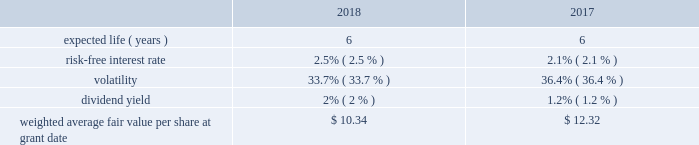Bhge 2018 form 10-k | 85 it is expected that the amount of unrecognized tax benefits will change in the next twelve months due to expiring statutes , audit activity , tax payments , and competent authority proceedings related to transfer pricing or final decisions in matters that are the subject of litigation in various taxing jurisdictions in which we operate .
At december 31 , 2018 , we had approximately $ 96 million of tax liabilities , net of $ 1 million of tax assets , related to uncertain tax positions , each of which are individually insignificant , and each of which are reasonably possible of being settled within the next twelve months .
We conduct business in more than 120 countries and are subject to income taxes in most taxing jurisdictions in which we operate .
All internal revenue service examinations have been completed and closed through year end 2015 for the most significant u.s .
Returns .
We believe there are no other jurisdictions in which the outcome of unresolved issues or claims is likely to be material to our results of operations , financial position or cash flows .
We further believe that we have made adequate provision for all income tax uncertainties .
Note 13 .
Stock-based compensation in july 2017 , we adopted the bhge 2017 long-term incentive plan ( lti plan ) under which we may grant stock options and other equity-based awards to employees and non-employee directors providing services to the company and our subsidiaries .
A total of up to 57.4 million shares of class a common stock are authorized for issuance pursuant to awards granted under the lti plan over its term which expires on the date of the annual meeting of the company in 2027 .
A total of 46.2 million shares of class a common stock are available for issuance as of december 31 , 2018 .
Stock-based compensation cost was $ 121 million and $ 37 million in 2018 and 2017 , respectively .
Stock-based compensation cost is measured at the date of grant based on the calculated fair value of the award and is generally recognized on a straight-line basis over the vesting period of the equity grant .
The compensation cost is determined based on awards ultimately expected to vest ; therefore , we have reduced the cost for estimated forfeitures based on historical forfeiture rates .
Forfeitures are estimated at the time of grant and revised , if necessary , in subsequent periods to reflect actual forfeitures .
There were no stock-based compensation costs capitalized as the amounts were not material .
Stock options we may grant stock options to our officers , directors and key employees .
Stock options generally vest in equal amounts over a three-year vesting period provided that the employee has remained continuously employed by the company through such vesting date .
The fair value of each stock option granted is estimated using the black- scholes option pricing model .
The table presents the weighted average assumptions used in the option pricing model for options granted under the lti plan .
The expected life of the options represents the period of time the options are expected to be outstanding .
The expected life is based on a simple average of the vesting term and original contractual term of the awards .
The expected volatility is based on the historical volatility of our five main competitors over a six year period .
The risk-free interest rate is based on the observed u.s .
Treasury yield curve in effect at the time the options were granted .
The dividend yield is based on a five year history of dividend payouts in baker hughes. .
Baker hughes , a ge company notes to consolidated and combined financial statements .
What is the percent change in weighted average fair value per share at grant date from 2017 to 2018? 
Computations: ((12.32 - 10.34) / 10.34)
Answer: 0.19149. Bhge 2018 form 10-k | 85 it is expected that the amount of unrecognized tax benefits will change in the next twelve months due to expiring statutes , audit activity , tax payments , and competent authority proceedings related to transfer pricing or final decisions in matters that are the subject of litigation in various taxing jurisdictions in which we operate .
At december 31 , 2018 , we had approximately $ 96 million of tax liabilities , net of $ 1 million of tax assets , related to uncertain tax positions , each of which are individually insignificant , and each of which are reasonably possible of being settled within the next twelve months .
We conduct business in more than 120 countries and are subject to income taxes in most taxing jurisdictions in which we operate .
All internal revenue service examinations have been completed and closed through year end 2015 for the most significant u.s .
Returns .
We believe there are no other jurisdictions in which the outcome of unresolved issues or claims is likely to be material to our results of operations , financial position or cash flows .
We further believe that we have made adequate provision for all income tax uncertainties .
Note 13 .
Stock-based compensation in july 2017 , we adopted the bhge 2017 long-term incentive plan ( lti plan ) under which we may grant stock options and other equity-based awards to employees and non-employee directors providing services to the company and our subsidiaries .
A total of up to 57.4 million shares of class a common stock are authorized for issuance pursuant to awards granted under the lti plan over its term which expires on the date of the annual meeting of the company in 2027 .
A total of 46.2 million shares of class a common stock are available for issuance as of december 31 , 2018 .
Stock-based compensation cost was $ 121 million and $ 37 million in 2018 and 2017 , respectively .
Stock-based compensation cost is measured at the date of grant based on the calculated fair value of the award and is generally recognized on a straight-line basis over the vesting period of the equity grant .
The compensation cost is determined based on awards ultimately expected to vest ; therefore , we have reduced the cost for estimated forfeitures based on historical forfeiture rates .
Forfeitures are estimated at the time of grant and revised , if necessary , in subsequent periods to reflect actual forfeitures .
There were no stock-based compensation costs capitalized as the amounts were not material .
Stock options we may grant stock options to our officers , directors and key employees .
Stock options generally vest in equal amounts over a three-year vesting period provided that the employee has remained continuously employed by the company through such vesting date .
The fair value of each stock option granted is estimated using the black- scholes option pricing model .
The table presents the weighted average assumptions used in the option pricing model for options granted under the lti plan .
The expected life of the options represents the period of time the options are expected to be outstanding .
The expected life is based on a simple average of the vesting term and original contractual term of the awards .
The expected volatility is based on the historical volatility of our five main competitors over a six year period .
The risk-free interest rate is based on the observed u.s .
Treasury yield curve in effect at the time the options were granted .
The dividend yield is based on a five year history of dividend payouts in baker hughes. .
Baker hughes , a ge company notes to consolidated and combined financial statements .
What is the dividend yield of the stock-based compensation cost in 2018? 
Computations: (2% * 121)
Answer: 2.42. Bhge 2018 form 10-k | 85 it is expected that the amount of unrecognized tax benefits will change in the next twelve months due to expiring statutes , audit activity , tax payments , and competent authority proceedings related to transfer pricing or final decisions in matters that are the subject of litigation in various taxing jurisdictions in which we operate .
At december 31 , 2018 , we had approximately $ 96 million of tax liabilities , net of $ 1 million of tax assets , related to uncertain tax positions , each of which are individually insignificant , and each of which are reasonably possible of being settled within the next twelve months .
We conduct business in more than 120 countries and are subject to income taxes in most taxing jurisdictions in which we operate .
All internal revenue service examinations have been completed and closed through year end 2015 for the most significant u.s .
Returns .
We believe there are no other jurisdictions in which the outcome of unresolved issues or claims is likely to be material to our results of operations , financial position or cash flows .
We further believe that we have made adequate provision for all income tax uncertainties .
Note 13 .
Stock-based compensation in july 2017 , we adopted the bhge 2017 long-term incentive plan ( lti plan ) under which we may grant stock options and other equity-based awards to employees and non-employee directors providing services to the company and our subsidiaries .
A total of up to 57.4 million shares of class a common stock are authorized for issuance pursuant to awards granted under the lti plan over its term which expires on the date of the annual meeting of the company in 2027 .
A total of 46.2 million shares of class a common stock are available for issuance as of december 31 , 2018 .
Stock-based compensation cost was $ 121 million and $ 37 million in 2018 and 2017 , respectively .
Stock-based compensation cost is measured at the date of grant based on the calculated fair value of the award and is generally recognized on a straight-line basis over the vesting period of the equity grant .
The compensation cost is determined based on awards ultimately expected to vest ; therefore , we have reduced the cost for estimated forfeitures based on historical forfeiture rates .
Forfeitures are estimated at the time of grant and revised , if necessary , in subsequent periods to reflect actual forfeitures .
There were no stock-based compensation costs capitalized as the amounts were not material .
Stock options we may grant stock options to our officers , directors and key employees .
Stock options generally vest in equal amounts over a three-year vesting period provided that the employee has remained continuously employed by the company through such vesting date .
The fair value of each stock option granted is estimated using the black- scholes option pricing model .
The table presents the weighted average assumptions used in the option pricing model for options granted under the lti plan .
The expected life of the options represents the period of time the options are expected to be outstanding .
The expected life is based on a simple average of the vesting term and original contractual term of the awards .
The expected volatility is based on the historical volatility of our five main competitors over a six year period .
The risk-free interest rate is based on the observed u.s .
Treasury yield curve in effect at the time the options were granted .
The dividend yield is based on a five year history of dividend payouts in baker hughes. .
Baker hughes , a ge company notes to consolidated and combined financial statements .
What is the growth rate in weighted average fair value per share from 2017 to 2018? 
Computations: ((10.34 - 12.32) / 12.32)
Answer: -0.16071. 